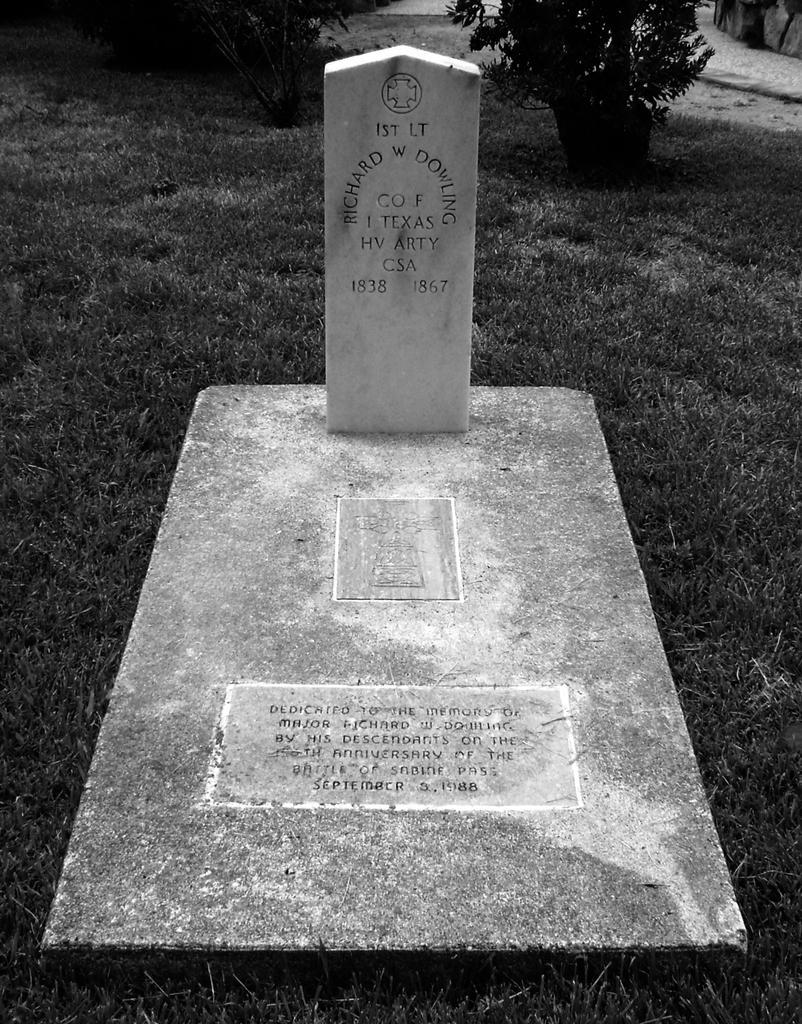In one or two sentences, can you explain what this image depicts? This is a black and white image. In this there is a grave with something written on that. On the ground there is grass. In the back there are plants. 